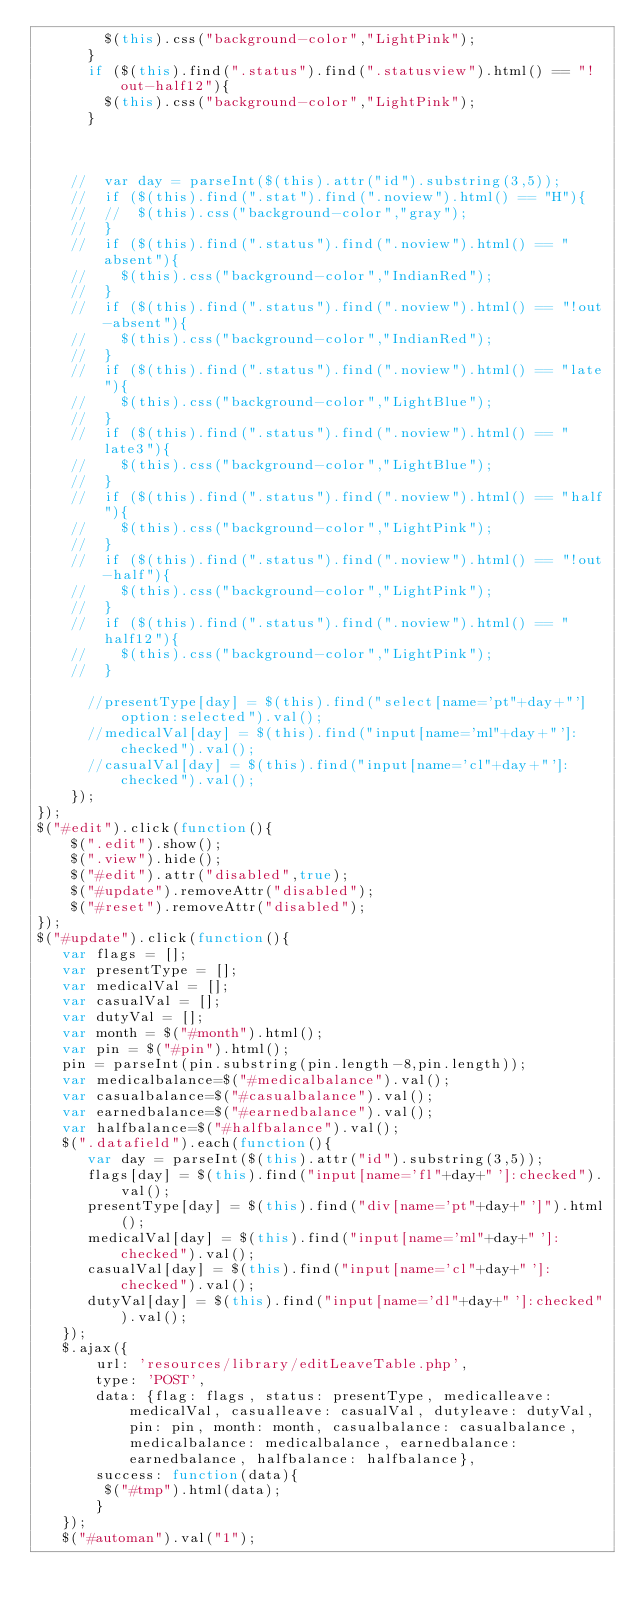Convert code to text. <code><loc_0><loc_0><loc_500><loc_500><_JavaScript_>			  $(this).css("background-color","LightPink");
			}
			if ($(this).find(".status").find(".statusview").html() == "!out-half12"){
			  $(this).css("background-color","LightPink");
			}

			
			
		//	var day = parseInt($(this).attr("id").substring(3,5));
		//	if ($(this).find(".stat").find(".noview").html() == "H"){
		//	//	$(this).css("background-color","gray");
		//	}
		//	if ($(this).find(".status").find(".noview").html() == "absent"){
		//		$(this).css("background-color","IndianRed");
		//	}
		//	if ($(this).find(".status").find(".noview").html() == "!out-absent"){
		//		$(this).css("background-color","IndianRed");
		//	}
		//	if ($(this).find(".status").find(".noview").html() == "late"){
		//		$(this).css("background-color","LightBlue");
		//	}
		//	if ($(this).find(".status").find(".noview").html() == "late3"){
		//		$(this).css("background-color","LightBlue");
		//	}
		//	if ($(this).find(".status").find(".noview").html() == "half"){
		//		$(this).css("background-color","LightPink");
		//	}
		//	if ($(this).find(".status").find(".noview").html() == "!out-half"){
		//		$(this).css("background-color","LightPink");
		//	}
		//	if ($(this).find(".status").find(".noview").html() == "half12"){
		//		$(this).css("background-color","LightPink");
		//	}

			//presentType[day] = $(this).find("select[name='pt"+day+"'] option:selected").val();
			//medicalVal[day] = $(this).find("input[name='ml"+day+"']:checked").val();
			//casualVal[day] = $(this).find("input[name='cl"+day+"']:checked").val();
		});
});
$("#edit").click(function(){
		$(".edit").show();
		$(".view").hide();
		$("#edit").attr("disabled",true);
		$("#update").removeAttr("disabled");
		$("#reset").removeAttr("disabled");
});
$("#update").click(function(){
	 var flags = [];
	 var presentType = [];
	 var medicalVal = [];
	 var casualVal = [];
	 var dutyVal = []; 
	 var month = $("#month").html(); 
	 var pin = $("#pin").html(); 
	 pin = parseInt(pin.substring(pin.length-8,pin.length));
	 var medicalbalance=$("#medicalbalance").val();
	 var casualbalance=$("#casualbalance").val();
	 var earnedbalance=$("#earnedbalance").val();
	 var halfbalance=$("#halfbalance").val();
	 $(".datafield").each(function(){
			var day = parseInt($(this).attr("id").substring(3,5));
			flags[day] = $(this).find("input[name='fl"+day+"']:checked").val();
			presentType[day] = $(this).find("div[name='pt"+day+"']").html();
			medicalVal[day] = $(this).find("input[name='ml"+day+"']:checked").val();
			casualVal[day] = $(this).find("input[name='cl"+day+"']:checked").val();
			dutyVal[day] = $(this).find("input[name='dl"+day+"']:checked").val();
	 });
	 $.ajax({
			 url: 'resources/library/editLeaveTable.php',
			 type: 'POST',
			 data: {flag: flags, status: presentType, medicalleave: medicalVal, casualleave: casualVal, dutyleave: dutyVal, pin: pin, month: month, casualbalance: casualbalance, medicalbalance: medicalbalance, earnedbalance: earnedbalance, halfbalance: halfbalance},
			 success: function(data){
				$("#tmp").html(data);
			 }
	 });	  
	 $("#automan").val("1");</code> 